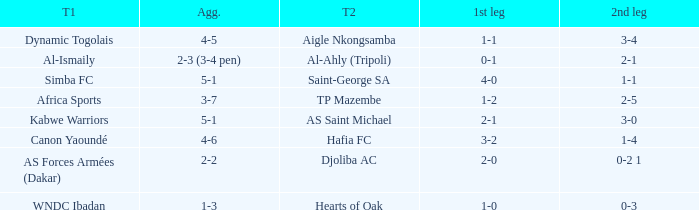What was the 2nd leg result in the match that scored a 2-0 in the 1st leg? 0-2 1. 